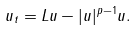Convert formula to latex. <formula><loc_0><loc_0><loc_500><loc_500>u _ { t } = L u - | u | ^ { p - 1 } u .</formula> 